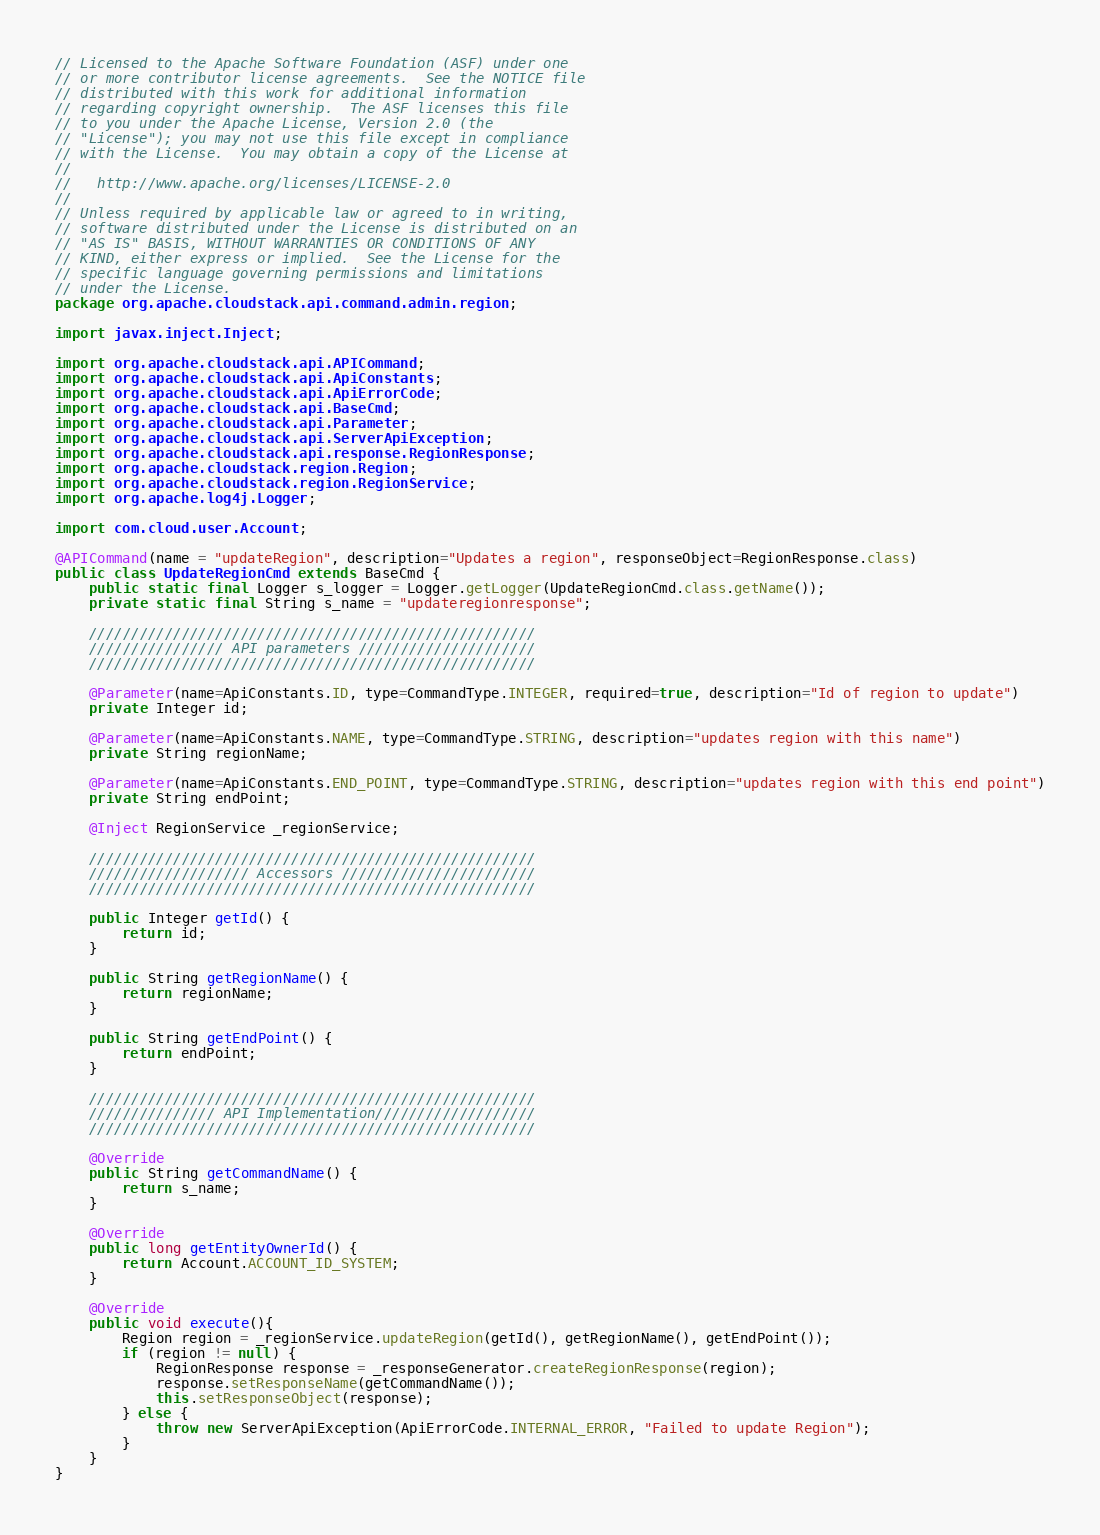<code> <loc_0><loc_0><loc_500><loc_500><_Java_>// Licensed to the Apache Software Foundation (ASF) under one
// or more contributor license agreements.  See the NOTICE file
// distributed with this work for additional information
// regarding copyright ownership.  The ASF licenses this file
// to you under the Apache License, Version 2.0 (the
// "License"); you may not use this file except in compliance
// with the License.  You may obtain a copy of the License at
//
//   http://www.apache.org/licenses/LICENSE-2.0
//
// Unless required by applicable law or agreed to in writing,
// software distributed under the License is distributed on an
// "AS IS" BASIS, WITHOUT WARRANTIES OR CONDITIONS OF ANY
// KIND, either express or implied.  See the License for the
// specific language governing permissions and limitations
// under the License.
package org.apache.cloudstack.api.command.admin.region;

import javax.inject.Inject;

import org.apache.cloudstack.api.APICommand;
import org.apache.cloudstack.api.ApiConstants;
import org.apache.cloudstack.api.ApiErrorCode;
import org.apache.cloudstack.api.BaseCmd;
import org.apache.cloudstack.api.Parameter;
import org.apache.cloudstack.api.ServerApiException;
import org.apache.cloudstack.api.response.RegionResponse;
import org.apache.cloudstack.region.Region;
import org.apache.cloudstack.region.RegionService;
import org.apache.log4j.Logger;

import com.cloud.user.Account;

@APICommand(name = "updateRegion", description="Updates a region", responseObject=RegionResponse.class)
public class UpdateRegionCmd extends BaseCmd {
    public static final Logger s_logger = Logger.getLogger(UpdateRegionCmd.class.getName());
    private static final String s_name = "updateregionresponse";

    /////////////////////////////////////////////////////
    //////////////// API parameters /////////////////////
    /////////////////////////////////////////////////////

    @Parameter(name=ApiConstants.ID, type=CommandType.INTEGER, required=true, description="Id of region to update")
    private Integer id;

    @Parameter(name=ApiConstants.NAME, type=CommandType.STRING, description="updates region with this name")
    private String regionName;
    
    @Parameter(name=ApiConstants.END_POINT, type=CommandType.STRING, description="updates region with this end point")
    private String endPoint;

    @Inject RegionService _regionService;
    
    /////////////////////////////////////////////////////
    /////////////////// Accessors ///////////////////////
    /////////////////////////////////////////////////////

    public Integer getId() {
        return id;
    }

    public String getRegionName() {
        return regionName;
    }
    
    public String getEndPoint() {
        return endPoint;
    }

    /////////////////////////////////////////////////////
    /////////////// API Implementation///////////////////
    /////////////////////////////////////////////////////

    @Override
    public String getCommandName() {
        return s_name;
    }
    
    @Override
    public long getEntityOwnerId() {
        return Account.ACCOUNT_ID_SYSTEM;
    }
    
    @Override
    public void execute(){
    	Region region = _regionService.updateRegion(getId(), getRegionName(), getEndPoint());
    	if (region != null) {
    		RegionResponse response = _responseGenerator.createRegionResponse(region);
    		response.setResponseName(getCommandName());
    		this.setResponseObject(response);
    	} else {
    		throw new ServerApiException(ApiErrorCode.INTERNAL_ERROR, "Failed to update Region");
    	}
    }
}
</code> 